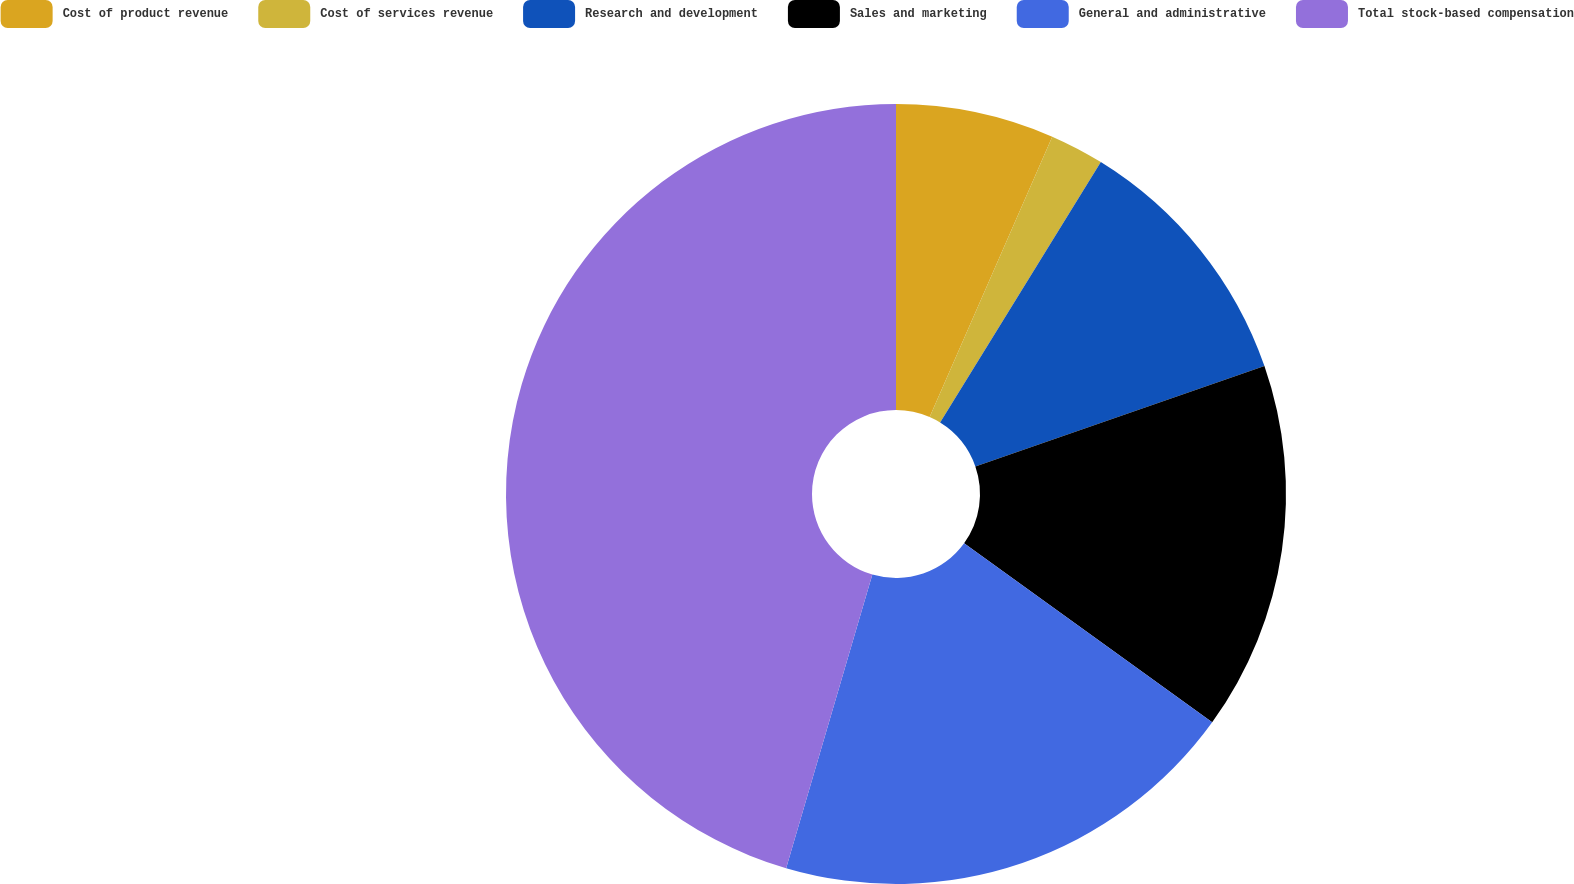Convert chart to OTSL. <chart><loc_0><loc_0><loc_500><loc_500><pie_chart><fcel>Cost of product revenue<fcel>Cost of services revenue<fcel>Research and development<fcel>Sales and marketing<fcel>General and administrative<fcel>Total stock-based compensation<nl><fcel>6.56%<fcel>2.24%<fcel>10.88%<fcel>15.27%<fcel>19.59%<fcel>45.45%<nl></chart> 